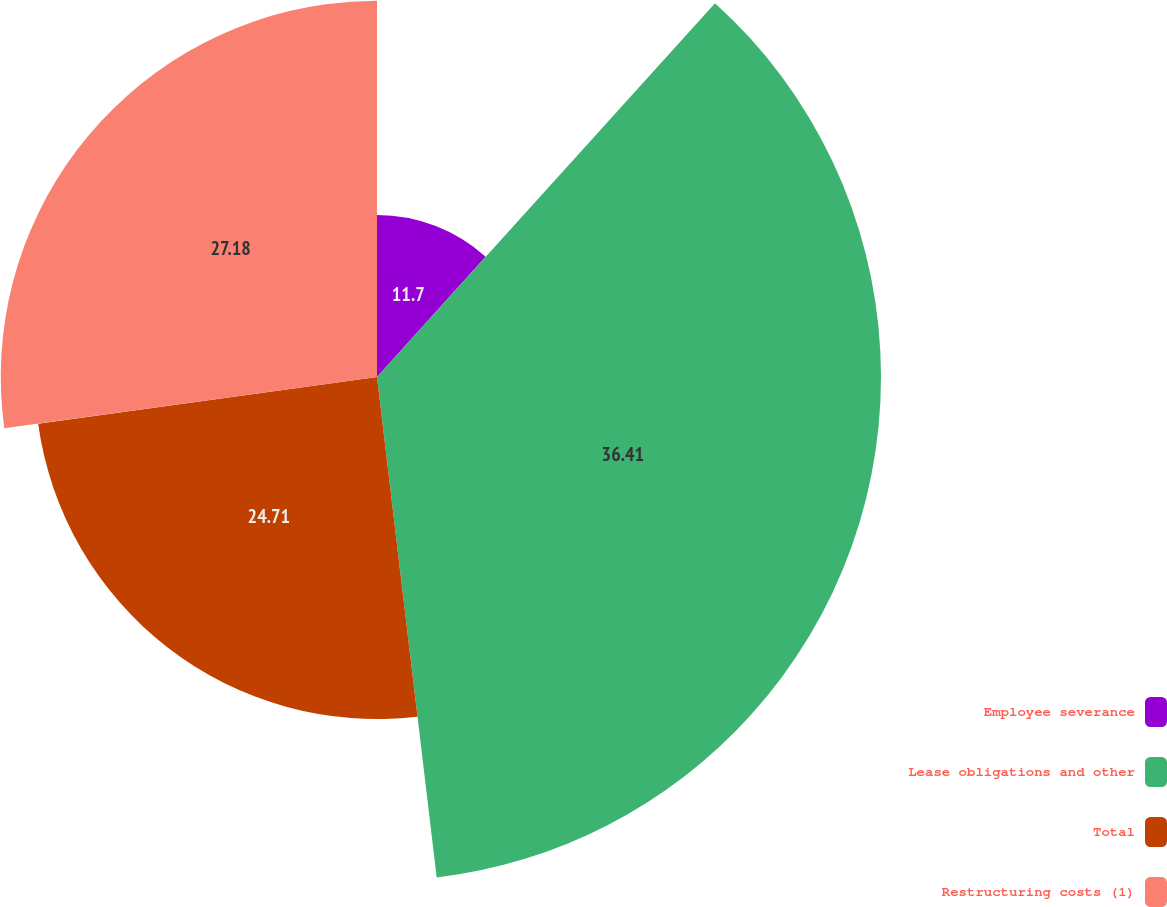<chart> <loc_0><loc_0><loc_500><loc_500><pie_chart><fcel>Employee severance<fcel>Lease obligations and other<fcel>Total<fcel>Restructuring costs (1)<nl><fcel>11.7%<fcel>36.41%<fcel>24.71%<fcel>27.18%<nl></chart> 